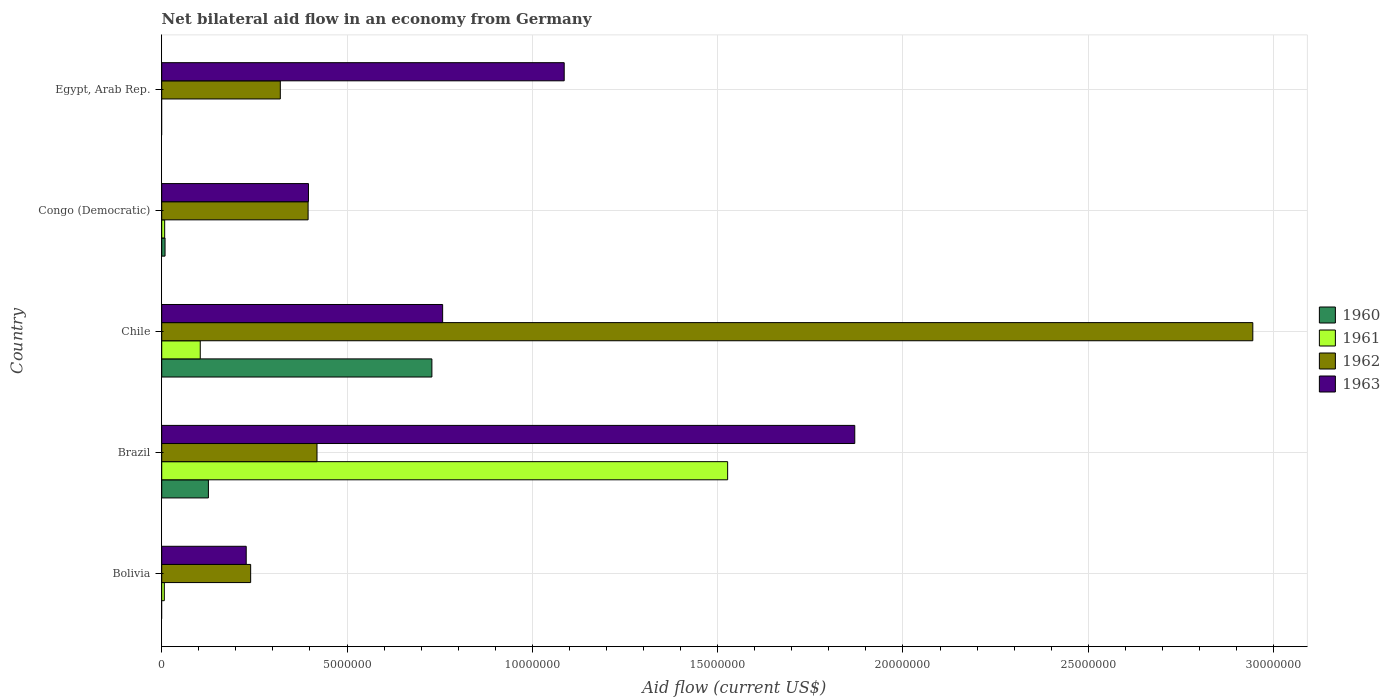Are the number of bars per tick equal to the number of legend labels?
Make the answer very short. No. Are the number of bars on each tick of the Y-axis equal?
Offer a terse response. No. How many bars are there on the 2nd tick from the bottom?
Your answer should be compact. 4. In how many cases, is the number of bars for a given country not equal to the number of legend labels?
Ensure brevity in your answer.  2. Across all countries, what is the maximum net bilateral aid flow in 1960?
Your answer should be compact. 7.29e+06. Across all countries, what is the minimum net bilateral aid flow in 1960?
Make the answer very short. 0. In which country was the net bilateral aid flow in 1961 maximum?
Make the answer very short. Brazil. What is the total net bilateral aid flow in 1963 in the graph?
Ensure brevity in your answer.  4.34e+07. What is the difference between the net bilateral aid flow in 1962 in Bolivia and that in Brazil?
Provide a short and direct response. -1.79e+06. What is the difference between the net bilateral aid flow in 1963 in Chile and the net bilateral aid flow in 1961 in Brazil?
Offer a very short reply. -7.69e+06. What is the average net bilateral aid flow in 1961 per country?
Your answer should be very brief. 3.29e+06. What is the difference between the net bilateral aid flow in 1962 and net bilateral aid flow in 1960 in Brazil?
Your answer should be very brief. 2.93e+06. What is the difference between the highest and the second highest net bilateral aid flow in 1961?
Ensure brevity in your answer.  1.42e+07. What is the difference between the highest and the lowest net bilateral aid flow in 1960?
Offer a terse response. 7.29e+06. In how many countries, is the net bilateral aid flow in 1962 greater than the average net bilateral aid flow in 1962 taken over all countries?
Give a very brief answer. 1. Is the sum of the net bilateral aid flow in 1963 in Bolivia and Chile greater than the maximum net bilateral aid flow in 1962 across all countries?
Provide a succinct answer. No. Are all the bars in the graph horizontal?
Your answer should be compact. Yes. Are the values on the major ticks of X-axis written in scientific E-notation?
Provide a short and direct response. No. Does the graph contain any zero values?
Provide a short and direct response. Yes. What is the title of the graph?
Ensure brevity in your answer.  Net bilateral aid flow in an economy from Germany. Does "1969" appear as one of the legend labels in the graph?
Your answer should be compact. No. What is the label or title of the X-axis?
Provide a short and direct response. Aid flow (current US$). What is the Aid flow (current US$) of 1960 in Bolivia?
Provide a short and direct response. 0. What is the Aid flow (current US$) in 1962 in Bolivia?
Offer a very short reply. 2.40e+06. What is the Aid flow (current US$) of 1963 in Bolivia?
Offer a very short reply. 2.28e+06. What is the Aid flow (current US$) of 1960 in Brazil?
Ensure brevity in your answer.  1.26e+06. What is the Aid flow (current US$) of 1961 in Brazil?
Offer a terse response. 1.53e+07. What is the Aid flow (current US$) of 1962 in Brazil?
Your answer should be compact. 4.19e+06. What is the Aid flow (current US$) of 1963 in Brazil?
Offer a very short reply. 1.87e+07. What is the Aid flow (current US$) in 1960 in Chile?
Provide a succinct answer. 7.29e+06. What is the Aid flow (current US$) in 1961 in Chile?
Ensure brevity in your answer.  1.04e+06. What is the Aid flow (current US$) of 1962 in Chile?
Your answer should be very brief. 2.94e+07. What is the Aid flow (current US$) of 1963 in Chile?
Your answer should be very brief. 7.58e+06. What is the Aid flow (current US$) of 1961 in Congo (Democratic)?
Offer a terse response. 8.00e+04. What is the Aid flow (current US$) in 1962 in Congo (Democratic)?
Keep it short and to the point. 3.95e+06. What is the Aid flow (current US$) in 1963 in Congo (Democratic)?
Give a very brief answer. 3.96e+06. What is the Aid flow (current US$) in 1960 in Egypt, Arab Rep.?
Give a very brief answer. 0. What is the Aid flow (current US$) in 1961 in Egypt, Arab Rep.?
Your answer should be very brief. 0. What is the Aid flow (current US$) in 1962 in Egypt, Arab Rep.?
Ensure brevity in your answer.  3.20e+06. What is the Aid flow (current US$) in 1963 in Egypt, Arab Rep.?
Your answer should be very brief. 1.09e+07. Across all countries, what is the maximum Aid flow (current US$) in 1960?
Offer a terse response. 7.29e+06. Across all countries, what is the maximum Aid flow (current US$) in 1961?
Keep it short and to the point. 1.53e+07. Across all countries, what is the maximum Aid flow (current US$) of 1962?
Your answer should be very brief. 2.94e+07. Across all countries, what is the maximum Aid flow (current US$) of 1963?
Make the answer very short. 1.87e+07. Across all countries, what is the minimum Aid flow (current US$) of 1960?
Offer a terse response. 0. Across all countries, what is the minimum Aid flow (current US$) in 1962?
Provide a succinct answer. 2.40e+06. Across all countries, what is the minimum Aid flow (current US$) in 1963?
Your response must be concise. 2.28e+06. What is the total Aid flow (current US$) of 1960 in the graph?
Offer a terse response. 8.64e+06. What is the total Aid flow (current US$) in 1961 in the graph?
Your response must be concise. 1.65e+07. What is the total Aid flow (current US$) of 1962 in the graph?
Ensure brevity in your answer.  4.32e+07. What is the total Aid flow (current US$) of 1963 in the graph?
Provide a short and direct response. 4.34e+07. What is the difference between the Aid flow (current US$) of 1961 in Bolivia and that in Brazil?
Your response must be concise. -1.52e+07. What is the difference between the Aid flow (current US$) of 1962 in Bolivia and that in Brazil?
Your answer should be very brief. -1.79e+06. What is the difference between the Aid flow (current US$) in 1963 in Bolivia and that in Brazil?
Ensure brevity in your answer.  -1.64e+07. What is the difference between the Aid flow (current US$) in 1961 in Bolivia and that in Chile?
Keep it short and to the point. -9.70e+05. What is the difference between the Aid flow (current US$) of 1962 in Bolivia and that in Chile?
Ensure brevity in your answer.  -2.70e+07. What is the difference between the Aid flow (current US$) of 1963 in Bolivia and that in Chile?
Offer a terse response. -5.30e+06. What is the difference between the Aid flow (current US$) of 1961 in Bolivia and that in Congo (Democratic)?
Offer a terse response. -10000. What is the difference between the Aid flow (current US$) in 1962 in Bolivia and that in Congo (Democratic)?
Offer a terse response. -1.55e+06. What is the difference between the Aid flow (current US$) in 1963 in Bolivia and that in Congo (Democratic)?
Your answer should be compact. -1.68e+06. What is the difference between the Aid flow (current US$) in 1962 in Bolivia and that in Egypt, Arab Rep.?
Your answer should be compact. -8.00e+05. What is the difference between the Aid flow (current US$) of 1963 in Bolivia and that in Egypt, Arab Rep.?
Ensure brevity in your answer.  -8.58e+06. What is the difference between the Aid flow (current US$) of 1960 in Brazil and that in Chile?
Make the answer very short. -6.03e+06. What is the difference between the Aid flow (current US$) in 1961 in Brazil and that in Chile?
Keep it short and to the point. 1.42e+07. What is the difference between the Aid flow (current US$) in 1962 in Brazil and that in Chile?
Make the answer very short. -2.52e+07. What is the difference between the Aid flow (current US$) of 1963 in Brazil and that in Chile?
Your response must be concise. 1.11e+07. What is the difference between the Aid flow (current US$) of 1960 in Brazil and that in Congo (Democratic)?
Give a very brief answer. 1.17e+06. What is the difference between the Aid flow (current US$) in 1961 in Brazil and that in Congo (Democratic)?
Ensure brevity in your answer.  1.52e+07. What is the difference between the Aid flow (current US$) in 1962 in Brazil and that in Congo (Democratic)?
Your answer should be compact. 2.40e+05. What is the difference between the Aid flow (current US$) in 1963 in Brazil and that in Congo (Democratic)?
Make the answer very short. 1.47e+07. What is the difference between the Aid flow (current US$) of 1962 in Brazil and that in Egypt, Arab Rep.?
Provide a short and direct response. 9.90e+05. What is the difference between the Aid flow (current US$) of 1963 in Brazil and that in Egypt, Arab Rep.?
Ensure brevity in your answer.  7.84e+06. What is the difference between the Aid flow (current US$) of 1960 in Chile and that in Congo (Democratic)?
Provide a succinct answer. 7.20e+06. What is the difference between the Aid flow (current US$) of 1961 in Chile and that in Congo (Democratic)?
Keep it short and to the point. 9.60e+05. What is the difference between the Aid flow (current US$) of 1962 in Chile and that in Congo (Democratic)?
Your response must be concise. 2.55e+07. What is the difference between the Aid flow (current US$) in 1963 in Chile and that in Congo (Democratic)?
Your response must be concise. 3.62e+06. What is the difference between the Aid flow (current US$) in 1962 in Chile and that in Egypt, Arab Rep.?
Your answer should be compact. 2.62e+07. What is the difference between the Aid flow (current US$) of 1963 in Chile and that in Egypt, Arab Rep.?
Ensure brevity in your answer.  -3.28e+06. What is the difference between the Aid flow (current US$) in 1962 in Congo (Democratic) and that in Egypt, Arab Rep.?
Your answer should be very brief. 7.50e+05. What is the difference between the Aid flow (current US$) of 1963 in Congo (Democratic) and that in Egypt, Arab Rep.?
Your response must be concise. -6.90e+06. What is the difference between the Aid flow (current US$) in 1961 in Bolivia and the Aid flow (current US$) in 1962 in Brazil?
Provide a short and direct response. -4.12e+06. What is the difference between the Aid flow (current US$) of 1961 in Bolivia and the Aid flow (current US$) of 1963 in Brazil?
Make the answer very short. -1.86e+07. What is the difference between the Aid flow (current US$) of 1962 in Bolivia and the Aid flow (current US$) of 1963 in Brazil?
Provide a short and direct response. -1.63e+07. What is the difference between the Aid flow (current US$) in 1961 in Bolivia and the Aid flow (current US$) in 1962 in Chile?
Ensure brevity in your answer.  -2.94e+07. What is the difference between the Aid flow (current US$) in 1961 in Bolivia and the Aid flow (current US$) in 1963 in Chile?
Offer a very short reply. -7.51e+06. What is the difference between the Aid flow (current US$) in 1962 in Bolivia and the Aid flow (current US$) in 1963 in Chile?
Give a very brief answer. -5.18e+06. What is the difference between the Aid flow (current US$) in 1961 in Bolivia and the Aid flow (current US$) in 1962 in Congo (Democratic)?
Your answer should be compact. -3.88e+06. What is the difference between the Aid flow (current US$) of 1961 in Bolivia and the Aid flow (current US$) of 1963 in Congo (Democratic)?
Provide a succinct answer. -3.89e+06. What is the difference between the Aid flow (current US$) of 1962 in Bolivia and the Aid flow (current US$) of 1963 in Congo (Democratic)?
Make the answer very short. -1.56e+06. What is the difference between the Aid flow (current US$) of 1961 in Bolivia and the Aid flow (current US$) of 1962 in Egypt, Arab Rep.?
Your response must be concise. -3.13e+06. What is the difference between the Aid flow (current US$) in 1961 in Bolivia and the Aid flow (current US$) in 1963 in Egypt, Arab Rep.?
Make the answer very short. -1.08e+07. What is the difference between the Aid flow (current US$) of 1962 in Bolivia and the Aid flow (current US$) of 1963 in Egypt, Arab Rep.?
Make the answer very short. -8.46e+06. What is the difference between the Aid flow (current US$) of 1960 in Brazil and the Aid flow (current US$) of 1962 in Chile?
Your answer should be very brief. -2.82e+07. What is the difference between the Aid flow (current US$) in 1960 in Brazil and the Aid flow (current US$) in 1963 in Chile?
Give a very brief answer. -6.32e+06. What is the difference between the Aid flow (current US$) in 1961 in Brazil and the Aid flow (current US$) in 1962 in Chile?
Give a very brief answer. -1.42e+07. What is the difference between the Aid flow (current US$) in 1961 in Brazil and the Aid flow (current US$) in 1963 in Chile?
Provide a short and direct response. 7.69e+06. What is the difference between the Aid flow (current US$) of 1962 in Brazil and the Aid flow (current US$) of 1963 in Chile?
Your response must be concise. -3.39e+06. What is the difference between the Aid flow (current US$) in 1960 in Brazil and the Aid flow (current US$) in 1961 in Congo (Democratic)?
Your answer should be very brief. 1.18e+06. What is the difference between the Aid flow (current US$) in 1960 in Brazil and the Aid flow (current US$) in 1962 in Congo (Democratic)?
Your answer should be very brief. -2.69e+06. What is the difference between the Aid flow (current US$) in 1960 in Brazil and the Aid flow (current US$) in 1963 in Congo (Democratic)?
Your answer should be compact. -2.70e+06. What is the difference between the Aid flow (current US$) of 1961 in Brazil and the Aid flow (current US$) of 1962 in Congo (Democratic)?
Ensure brevity in your answer.  1.13e+07. What is the difference between the Aid flow (current US$) of 1961 in Brazil and the Aid flow (current US$) of 1963 in Congo (Democratic)?
Offer a terse response. 1.13e+07. What is the difference between the Aid flow (current US$) of 1960 in Brazil and the Aid flow (current US$) of 1962 in Egypt, Arab Rep.?
Your response must be concise. -1.94e+06. What is the difference between the Aid flow (current US$) of 1960 in Brazil and the Aid flow (current US$) of 1963 in Egypt, Arab Rep.?
Your response must be concise. -9.60e+06. What is the difference between the Aid flow (current US$) of 1961 in Brazil and the Aid flow (current US$) of 1962 in Egypt, Arab Rep.?
Provide a short and direct response. 1.21e+07. What is the difference between the Aid flow (current US$) of 1961 in Brazil and the Aid flow (current US$) of 1963 in Egypt, Arab Rep.?
Your response must be concise. 4.41e+06. What is the difference between the Aid flow (current US$) of 1962 in Brazil and the Aid flow (current US$) of 1963 in Egypt, Arab Rep.?
Give a very brief answer. -6.67e+06. What is the difference between the Aid flow (current US$) of 1960 in Chile and the Aid flow (current US$) of 1961 in Congo (Democratic)?
Your answer should be very brief. 7.21e+06. What is the difference between the Aid flow (current US$) of 1960 in Chile and the Aid flow (current US$) of 1962 in Congo (Democratic)?
Provide a succinct answer. 3.34e+06. What is the difference between the Aid flow (current US$) in 1960 in Chile and the Aid flow (current US$) in 1963 in Congo (Democratic)?
Ensure brevity in your answer.  3.33e+06. What is the difference between the Aid flow (current US$) of 1961 in Chile and the Aid flow (current US$) of 1962 in Congo (Democratic)?
Ensure brevity in your answer.  -2.91e+06. What is the difference between the Aid flow (current US$) in 1961 in Chile and the Aid flow (current US$) in 1963 in Congo (Democratic)?
Your answer should be very brief. -2.92e+06. What is the difference between the Aid flow (current US$) in 1962 in Chile and the Aid flow (current US$) in 1963 in Congo (Democratic)?
Keep it short and to the point. 2.55e+07. What is the difference between the Aid flow (current US$) of 1960 in Chile and the Aid flow (current US$) of 1962 in Egypt, Arab Rep.?
Ensure brevity in your answer.  4.09e+06. What is the difference between the Aid flow (current US$) of 1960 in Chile and the Aid flow (current US$) of 1963 in Egypt, Arab Rep.?
Give a very brief answer. -3.57e+06. What is the difference between the Aid flow (current US$) of 1961 in Chile and the Aid flow (current US$) of 1962 in Egypt, Arab Rep.?
Provide a short and direct response. -2.16e+06. What is the difference between the Aid flow (current US$) of 1961 in Chile and the Aid flow (current US$) of 1963 in Egypt, Arab Rep.?
Your answer should be very brief. -9.82e+06. What is the difference between the Aid flow (current US$) of 1962 in Chile and the Aid flow (current US$) of 1963 in Egypt, Arab Rep.?
Make the answer very short. 1.86e+07. What is the difference between the Aid flow (current US$) in 1960 in Congo (Democratic) and the Aid flow (current US$) in 1962 in Egypt, Arab Rep.?
Offer a terse response. -3.11e+06. What is the difference between the Aid flow (current US$) in 1960 in Congo (Democratic) and the Aid flow (current US$) in 1963 in Egypt, Arab Rep.?
Your answer should be compact. -1.08e+07. What is the difference between the Aid flow (current US$) of 1961 in Congo (Democratic) and the Aid flow (current US$) of 1962 in Egypt, Arab Rep.?
Give a very brief answer. -3.12e+06. What is the difference between the Aid flow (current US$) of 1961 in Congo (Democratic) and the Aid flow (current US$) of 1963 in Egypt, Arab Rep.?
Keep it short and to the point. -1.08e+07. What is the difference between the Aid flow (current US$) of 1962 in Congo (Democratic) and the Aid flow (current US$) of 1963 in Egypt, Arab Rep.?
Provide a short and direct response. -6.91e+06. What is the average Aid flow (current US$) of 1960 per country?
Your answer should be very brief. 1.73e+06. What is the average Aid flow (current US$) of 1961 per country?
Provide a short and direct response. 3.29e+06. What is the average Aid flow (current US$) of 1962 per country?
Offer a terse response. 8.64e+06. What is the average Aid flow (current US$) of 1963 per country?
Your answer should be very brief. 8.68e+06. What is the difference between the Aid flow (current US$) in 1961 and Aid flow (current US$) in 1962 in Bolivia?
Offer a very short reply. -2.33e+06. What is the difference between the Aid flow (current US$) of 1961 and Aid flow (current US$) of 1963 in Bolivia?
Offer a terse response. -2.21e+06. What is the difference between the Aid flow (current US$) of 1960 and Aid flow (current US$) of 1961 in Brazil?
Provide a short and direct response. -1.40e+07. What is the difference between the Aid flow (current US$) of 1960 and Aid flow (current US$) of 1962 in Brazil?
Provide a short and direct response. -2.93e+06. What is the difference between the Aid flow (current US$) in 1960 and Aid flow (current US$) in 1963 in Brazil?
Provide a short and direct response. -1.74e+07. What is the difference between the Aid flow (current US$) of 1961 and Aid flow (current US$) of 1962 in Brazil?
Make the answer very short. 1.11e+07. What is the difference between the Aid flow (current US$) of 1961 and Aid flow (current US$) of 1963 in Brazil?
Give a very brief answer. -3.43e+06. What is the difference between the Aid flow (current US$) in 1962 and Aid flow (current US$) in 1963 in Brazil?
Offer a terse response. -1.45e+07. What is the difference between the Aid flow (current US$) in 1960 and Aid flow (current US$) in 1961 in Chile?
Ensure brevity in your answer.  6.25e+06. What is the difference between the Aid flow (current US$) in 1960 and Aid flow (current US$) in 1962 in Chile?
Provide a short and direct response. -2.22e+07. What is the difference between the Aid flow (current US$) in 1960 and Aid flow (current US$) in 1963 in Chile?
Offer a terse response. -2.90e+05. What is the difference between the Aid flow (current US$) in 1961 and Aid flow (current US$) in 1962 in Chile?
Your answer should be very brief. -2.84e+07. What is the difference between the Aid flow (current US$) of 1961 and Aid flow (current US$) of 1963 in Chile?
Offer a very short reply. -6.54e+06. What is the difference between the Aid flow (current US$) of 1962 and Aid flow (current US$) of 1963 in Chile?
Provide a short and direct response. 2.19e+07. What is the difference between the Aid flow (current US$) of 1960 and Aid flow (current US$) of 1962 in Congo (Democratic)?
Ensure brevity in your answer.  -3.86e+06. What is the difference between the Aid flow (current US$) in 1960 and Aid flow (current US$) in 1963 in Congo (Democratic)?
Make the answer very short. -3.87e+06. What is the difference between the Aid flow (current US$) of 1961 and Aid flow (current US$) of 1962 in Congo (Democratic)?
Your answer should be very brief. -3.87e+06. What is the difference between the Aid flow (current US$) of 1961 and Aid flow (current US$) of 1963 in Congo (Democratic)?
Offer a very short reply. -3.88e+06. What is the difference between the Aid flow (current US$) of 1962 and Aid flow (current US$) of 1963 in Egypt, Arab Rep.?
Provide a short and direct response. -7.66e+06. What is the ratio of the Aid flow (current US$) in 1961 in Bolivia to that in Brazil?
Provide a succinct answer. 0. What is the ratio of the Aid flow (current US$) in 1962 in Bolivia to that in Brazil?
Offer a very short reply. 0.57. What is the ratio of the Aid flow (current US$) of 1963 in Bolivia to that in Brazil?
Offer a terse response. 0.12. What is the ratio of the Aid flow (current US$) of 1961 in Bolivia to that in Chile?
Provide a succinct answer. 0.07. What is the ratio of the Aid flow (current US$) of 1962 in Bolivia to that in Chile?
Provide a short and direct response. 0.08. What is the ratio of the Aid flow (current US$) in 1963 in Bolivia to that in Chile?
Make the answer very short. 0.3. What is the ratio of the Aid flow (current US$) of 1961 in Bolivia to that in Congo (Democratic)?
Ensure brevity in your answer.  0.88. What is the ratio of the Aid flow (current US$) in 1962 in Bolivia to that in Congo (Democratic)?
Ensure brevity in your answer.  0.61. What is the ratio of the Aid flow (current US$) in 1963 in Bolivia to that in Congo (Democratic)?
Provide a short and direct response. 0.58. What is the ratio of the Aid flow (current US$) of 1962 in Bolivia to that in Egypt, Arab Rep.?
Your response must be concise. 0.75. What is the ratio of the Aid flow (current US$) in 1963 in Bolivia to that in Egypt, Arab Rep.?
Your answer should be very brief. 0.21. What is the ratio of the Aid flow (current US$) of 1960 in Brazil to that in Chile?
Keep it short and to the point. 0.17. What is the ratio of the Aid flow (current US$) in 1961 in Brazil to that in Chile?
Give a very brief answer. 14.68. What is the ratio of the Aid flow (current US$) of 1962 in Brazil to that in Chile?
Offer a terse response. 0.14. What is the ratio of the Aid flow (current US$) in 1963 in Brazil to that in Chile?
Offer a very short reply. 2.47. What is the ratio of the Aid flow (current US$) in 1961 in Brazil to that in Congo (Democratic)?
Your answer should be compact. 190.88. What is the ratio of the Aid flow (current US$) of 1962 in Brazil to that in Congo (Democratic)?
Provide a short and direct response. 1.06. What is the ratio of the Aid flow (current US$) of 1963 in Brazil to that in Congo (Democratic)?
Ensure brevity in your answer.  4.72. What is the ratio of the Aid flow (current US$) of 1962 in Brazil to that in Egypt, Arab Rep.?
Keep it short and to the point. 1.31. What is the ratio of the Aid flow (current US$) of 1963 in Brazil to that in Egypt, Arab Rep.?
Your answer should be compact. 1.72. What is the ratio of the Aid flow (current US$) in 1961 in Chile to that in Congo (Democratic)?
Your answer should be very brief. 13. What is the ratio of the Aid flow (current US$) of 1962 in Chile to that in Congo (Democratic)?
Your answer should be compact. 7.45. What is the ratio of the Aid flow (current US$) of 1963 in Chile to that in Congo (Democratic)?
Offer a very short reply. 1.91. What is the ratio of the Aid flow (current US$) in 1962 in Chile to that in Egypt, Arab Rep.?
Provide a succinct answer. 9.2. What is the ratio of the Aid flow (current US$) of 1963 in Chile to that in Egypt, Arab Rep.?
Your answer should be very brief. 0.7. What is the ratio of the Aid flow (current US$) of 1962 in Congo (Democratic) to that in Egypt, Arab Rep.?
Make the answer very short. 1.23. What is the ratio of the Aid flow (current US$) of 1963 in Congo (Democratic) to that in Egypt, Arab Rep.?
Your answer should be compact. 0.36. What is the difference between the highest and the second highest Aid flow (current US$) of 1960?
Offer a terse response. 6.03e+06. What is the difference between the highest and the second highest Aid flow (current US$) in 1961?
Offer a very short reply. 1.42e+07. What is the difference between the highest and the second highest Aid flow (current US$) of 1962?
Make the answer very short. 2.52e+07. What is the difference between the highest and the second highest Aid flow (current US$) in 1963?
Keep it short and to the point. 7.84e+06. What is the difference between the highest and the lowest Aid flow (current US$) of 1960?
Your answer should be very brief. 7.29e+06. What is the difference between the highest and the lowest Aid flow (current US$) of 1961?
Offer a terse response. 1.53e+07. What is the difference between the highest and the lowest Aid flow (current US$) of 1962?
Provide a succinct answer. 2.70e+07. What is the difference between the highest and the lowest Aid flow (current US$) of 1963?
Provide a short and direct response. 1.64e+07. 